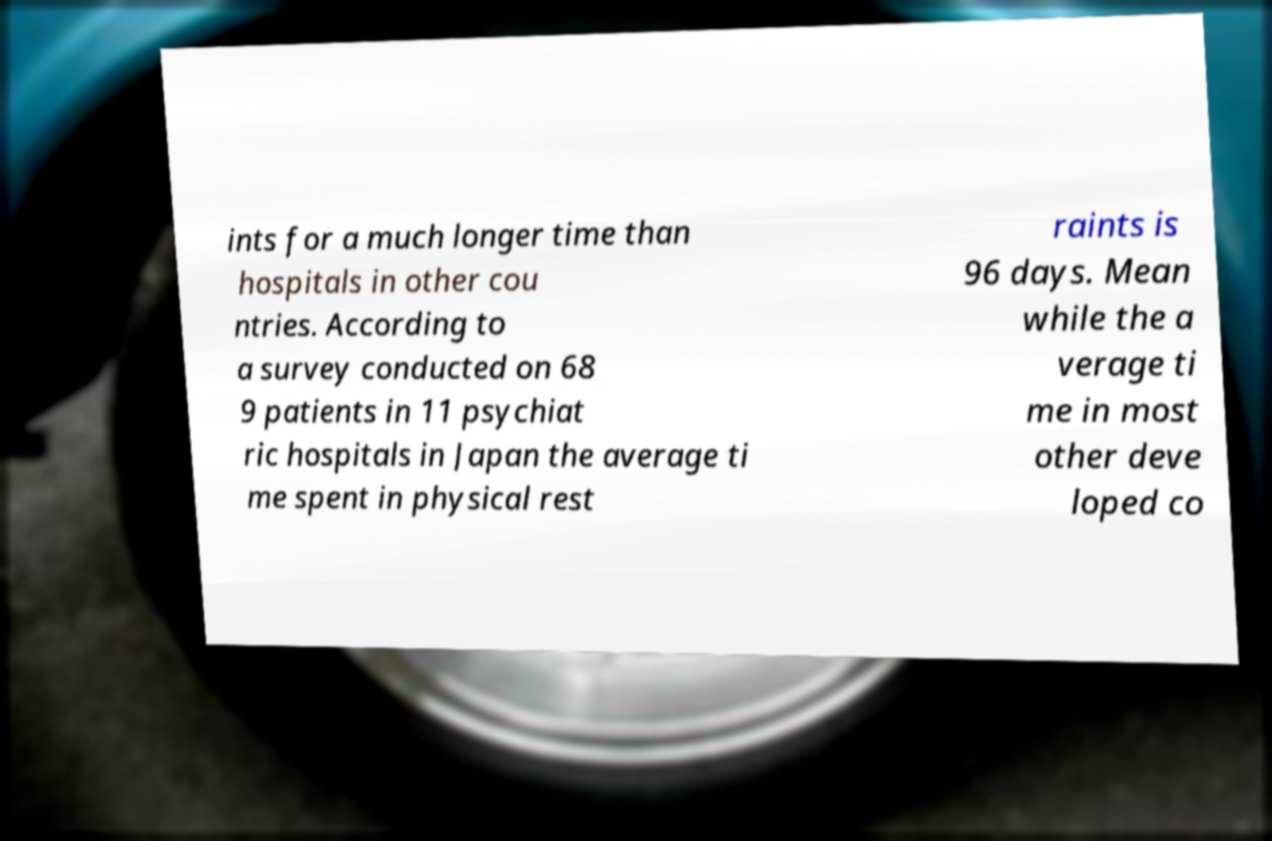Can you accurately transcribe the text from the provided image for me? ints for a much longer time than hospitals in other cou ntries. According to a survey conducted on 68 9 patients in 11 psychiat ric hospitals in Japan the average ti me spent in physical rest raints is 96 days. Mean while the a verage ti me in most other deve loped co 